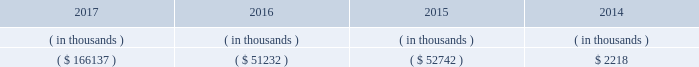Entergy arkansas 2019s receivables from or ( payables to ) the money pool were as follows as of december 31 for each of the following years. .
See note 4 to the financial statements for a description of the money pool .
Entergy arkansas has a credit facility in the amount of $ 150 million scheduled to expire in august 2022 .
Entergy arkansas also has a $ 20 million credit facility scheduled to expire in april 2018 . a0 a0the $ 150 million credit facility permits the issuance of letters of credit against $ 5 million of the borrowing capacity of the facility .
As of december 31 , 2017 , there were no cash borrowings and no letters of credit outstanding under the credit facilities .
In addition , entergy arkansas is a party to an uncommitted letter of credit facility as a means to post collateral to support its obligations to miso .
As of december 31 , 2017 , a $ 1 million letter of credit was outstanding under entergy arkansas 2019s uncommitted letter of credit facility .
See note 4 to the financial statements for further discussion of the credit facilities .
The entergy arkansas nuclear fuel company variable interest entity has a credit facility in the amount of $ 80 million scheduled to expire in may 2019 . a0 a0as of december 31 , 2017 , $ 50 million in letters of credit to support a like amount of commercial paper issued and $ 24.9 million in loans were outstanding under the entergy arkansas nuclear fuel company variable interest entity credit facility .
See note 4 to the financial statements for further discussion of the nuclear fuel company variable interest entity credit facility .
Entergy arkansas obtained authorizations from the ferc through october 2019 for short-term borrowings not to exceed an aggregate amount of $ 250 million at any time outstanding and borrowings by its nuclear fuel company variable interest entity .
See note 4 to the financial statements for further discussion of entergy arkansas 2019s short-term borrowing limits .
The long-term securities issuances of entergy arkansas are limited to amounts authorized by the apsc , and the current authorization extends through december 2018 .
Entergy arkansas , inc .
And subsidiaries management 2019s financial discussion and analysis state and local rate regulation and fuel-cost recovery retail rates 2015 base rate filing in april 2015 , entergy arkansas filed with the apsc for a general change in rates , charges , and tariffs .
The filing notified the apsc of entergy arkansas 2019s intent to implement a forward test year formula rate plan pursuant to arkansas legislation passed in 2015 , and requested a retail rate increase of $ 268.4 million , with a net increase in revenue of $ 167 million .
The filing requested a 10.2% ( 10.2 % ) return on common equity .
In september 2015 the apsc staff and intervenors filed direct testimony , with the apsc staff recommending a revenue requirement of $ 217.9 million and a 9.65% ( 9.65 % ) return on common equity .
In december 2015 , entergy arkansas , the apsc staff , and certain of the intervenors in the rate case filed with the apsc a joint motion for approval of a settlement of the case that proposed a retail rate increase of approximately $ 225 million with a net increase in revenue of approximately $ 133 million ; an authorized return on common equity of 9.75% ( 9.75 % ) ; and a formula rate plan tariff that provides a +/- 50 basis point band around the 9.75% ( 9.75 % ) allowed return on common equity .
A significant portion of the rate increase is related to entergy arkansas 2019s acquisition in march 2016 of union power station power block 2 for a base purchase price of $ 237 million .
The settlement agreement also provided for amortization over a 10-year period of $ 7.7 million of previously-incurred costs related to ano post-fukushima compliance and $ 9.9 million of previously-incurred costs related to ano flood barrier compliance .
A settlement hearing was held in january 2016 .
In february 2016 the apsc approved the settlement with one exception that reduced the retail rate increase proposed in the settlement by $ 5 million .
The settling parties agreed to the apsc modifications in february 2016 .
The new rates were effective february 24 , 2016 and began billing with the first billing cycle of april 2016 .
In march 2016 , entergy arkansas made a compliance filing regarding the .
In 2016 as part of the entergy arkansas 2019s intent to implement a forward test year formula rate plan pursuant to arkansas legislation passed in 2015 , what was the ratio of the and requested a retail rate increase to the net increase? 
Computations: (268.4 / 167)
Answer: 1.60719. Entergy arkansas 2019s receivables from or ( payables to ) the money pool were as follows as of december 31 for each of the following years. .
See note 4 to the financial statements for a description of the money pool .
Entergy arkansas has a credit facility in the amount of $ 150 million scheduled to expire in august 2022 .
Entergy arkansas also has a $ 20 million credit facility scheduled to expire in april 2018 . a0 a0the $ 150 million credit facility permits the issuance of letters of credit against $ 5 million of the borrowing capacity of the facility .
As of december 31 , 2017 , there were no cash borrowings and no letters of credit outstanding under the credit facilities .
In addition , entergy arkansas is a party to an uncommitted letter of credit facility as a means to post collateral to support its obligations to miso .
As of december 31 , 2017 , a $ 1 million letter of credit was outstanding under entergy arkansas 2019s uncommitted letter of credit facility .
See note 4 to the financial statements for further discussion of the credit facilities .
The entergy arkansas nuclear fuel company variable interest entity has a credit facility in the amount of $ 80 million scheduled to expire in may 2019 . a0 a0as of december 31 , 2017 , $ 50 million in letters of credit to support a like amount of commercial paper issued and $ 24.9 million in loans were outstanding under the entergy arkansas nuclear fuel company variable interest entity credit facility .
See note 4 to the financial statements for further discussion of the nuclear fuel company variable interest entity credit facility .
Entergy arkansas obtained authorizations from the ferc through october 2019 for short-term borrowings not to exceed an aggregate amount of $ 250 million at any time outstanding and borrowings by its nuclear fuel company variable interest entity .
See note 4 to the financial statements for further discussion of entergy arkansas 2019s short-term borrowing limits .
The long-term securities issuances of entergy arkansas are limited to amounts authorized by the apsc , and the current authorization extends through december 2018 .
Entergy arkansas , inc .
And subsidiaries management 2019s financial discussion and analysis state and local rate regulation and fuel-cost recovery retail rates 2015 base rate filing in april 2015 , entergy arkansas filed with the apsc for a general change in rates , charges , and tariffs .
The filing notified the apsc of entergy arkansas 2019s intent to implement a forward test year formula rate plan pursuant to arkansas legislation passed in 2015 , and requested a retail rate increase of $ 268.4 million , with a net increase in revenue of $ 167 million .
The filing requested a 10.2% ( 10.2 % ) return on common equity .
In september 2015 the apsc staff and intervenors filed direct testimony , with the apsc staff recommending a revenue requirement of $ 217.9 million and a 9.65% ( 9.65 % ) return on common equity .
In december 2015 , entergy arkansas , the apsc staff , and certain of the intervenors in the rate case filed with the apsc a joint motion for approval of a settlement of the case that proposed a retail rate increase of approximately $ 225 million with a net increase in revenue of approximately $ 133 million ; an authorized return on common equity of 9.75% ( 9.75 % ) ; and a formula rate plan tariff that provides a +/- 50 basis point band around the 9.75% ( 9.75 % ) allowed return on common equity .
A significant portion of the rate increase is related to entergy arkansas 2019s acquisition in march 2016 of union power station power block 2 for a base purchase price of $ 237 million .
The settlement agreement also provided for amortization over a 10-year period of $ 7.7 million of previously-incurred costs related to ano post-fukushima compliance and $ 9.9 million of previously-incurred costs related to ano flood barrier compliance .
A settlement hearing was held in january 2016 .
In february 2016 the apsc approved the settlement with one exception that reduced the retail rate increase proposed in the settlement by $ 5 million .
The settling parties agreed to the apsc modifications in february 2016 .
The new rates were effective february 24 , 2016 and began billing with the first billing cycle of april 2016 .
In march 2016 , entergy arkansas made a compliance filing regarding the .
What percent of the aggregate borrowing capacity is set to expire in 2019? 
Computations: (80 / 250)
Answer: 0.32. 